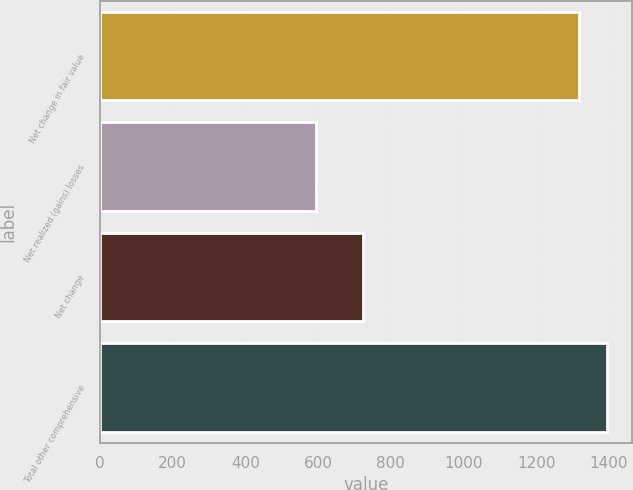Convert chart. <chart><loc_0><loc_0><loc_500><loc_500><bar_chart><fcel>Net change in fair value<fcel>Net realized (gains) losses<fcel>Net change<fcel>Total other comprehensive<nl><fcel>1319<fcel>595<fcel>724<fcel>1393.7<nl></chart> 